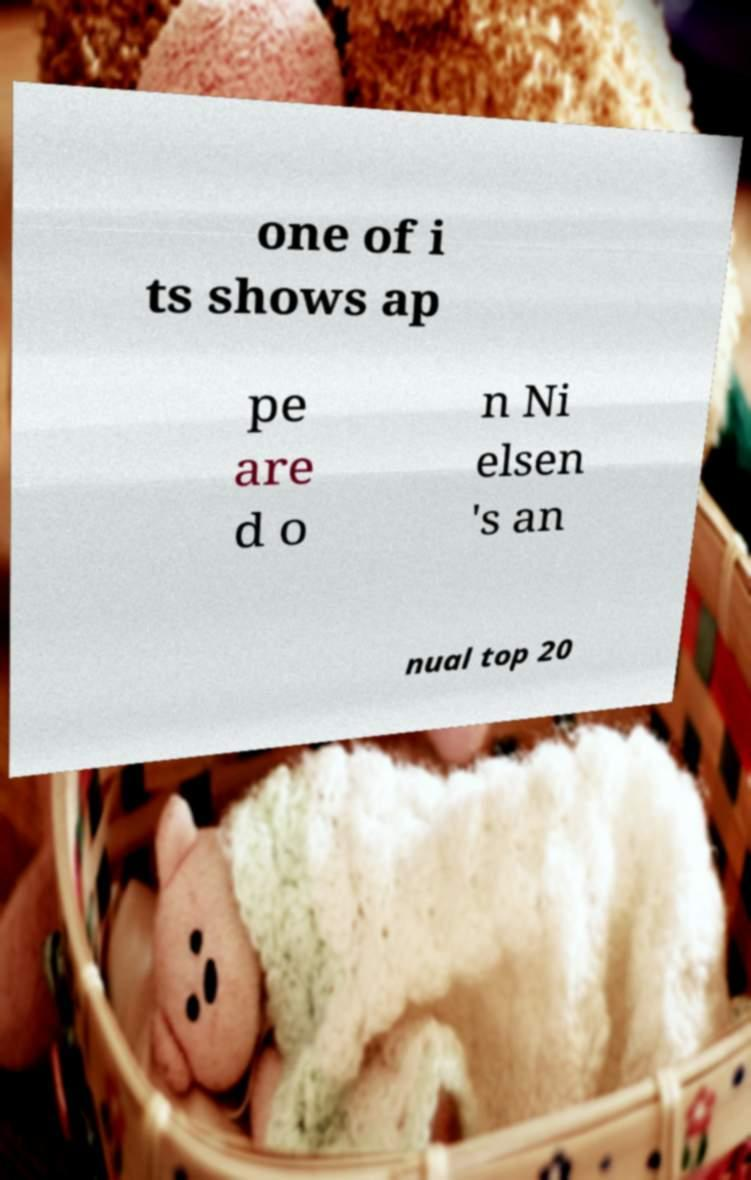There's text embedded in this image that I need extracted. Can you transcribe it verbatim? one of i ts shows ap pe are d o n Ni elsen 's an nual top 20 